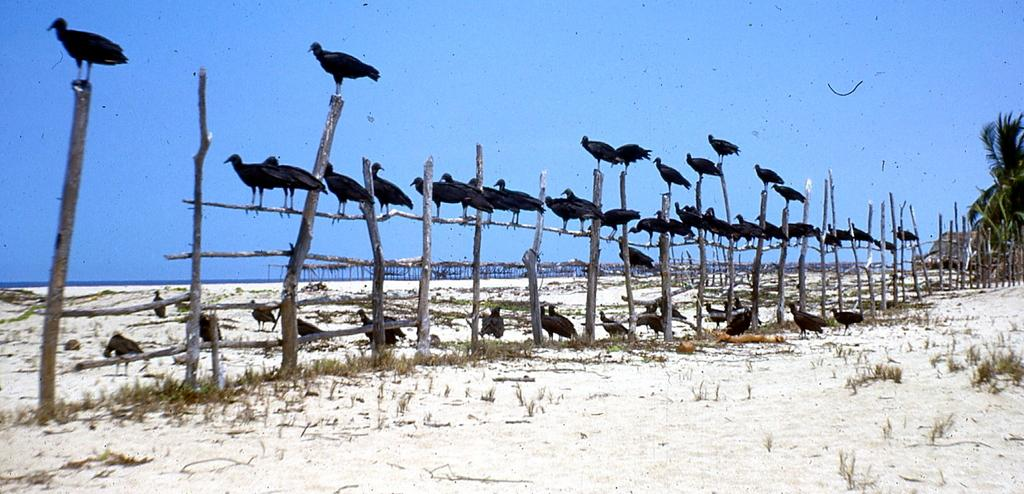What type of animals can be seen in the image? There are birds in the image. What type of vegetation is present in the image? There are trees in the image. What type of barrier can be seen in the image? There is a fence in the image. What is visible in the background of the image? The sky is visible in the image. What time of day is it in the image, and is the father present with the deer? The time of day cannot be determined from the image, and there are no people or deer present in the image. 